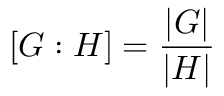Convert formula to latex. <formula><loc_0><loc_0><loc_500><loc_500>[ G \colon H ] = { \frac { | G | } { | H | } }</formula> 